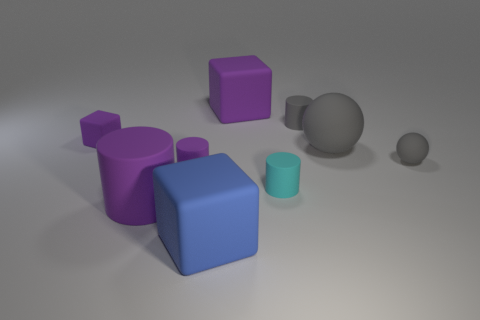Subtract all big purple matte blocks. How many blocks are left? 2 Add 1 green cubes. How many objects exist? 10 Subtract all yellow cylinders. How many purple cubes are left? 2 Subtract all purple cylinders. How many cylinders are left? 2 Subtract all cubes. How many objects are left? 6 Subtract 1 balls. How many balls are left? 1 Subtract all cyan cylinders. Subtract all red blocks. How many cylinders are left? 3 Subtract all matte cylinders. Subtract all large gray matte things. How many objects are left? 4 Add 1 gray cylinders. How many gray cylinders are left? 2 Add 3 small blocks. How many small blocks exist? 4 